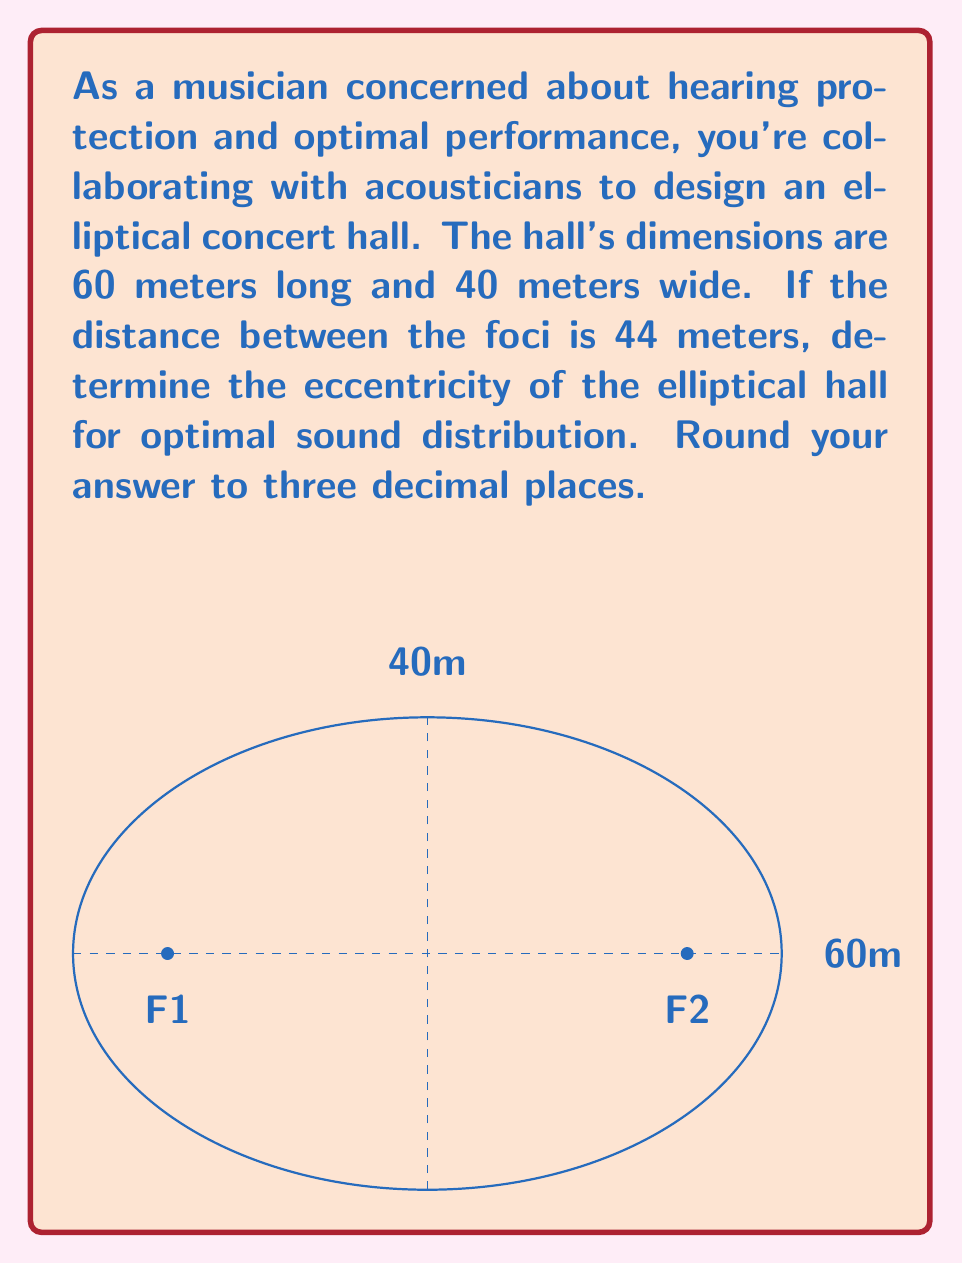Help me with this question. Let's approach this step-by-step:

1) The eccentricity of an ellipse is defined as:

   $$e = \frac{c}{a}$$

   where $c$ is half the distance between the foci, and $a$ is the length of the semi-major axis.

2) We're given:
   - Length of the hall = 60 meters
   - Width of the hall = 40 meters
   - Distance between foci = 44 meters

3) The semi-major axis $a$ is half the length:
   $$a = \frac{60}{2} = 30\text{ meters}$$

4) Half the distance between the foci is:
   $$c = \frac{44}{2} = 22\text{ meters}$$

5) Now we can calculate the eccentricity:

   $$e = \frac{c}{a} = \frac{22}{30} \approx 0.733$$

6) Rounding to three decimal places:
   $$e \approx 0.733$$

This eccentricity value indicates that the ellipse is moderately elongated, which can help in distributing sound evenly throughout the concert hall.
Answer: $0.733$ 